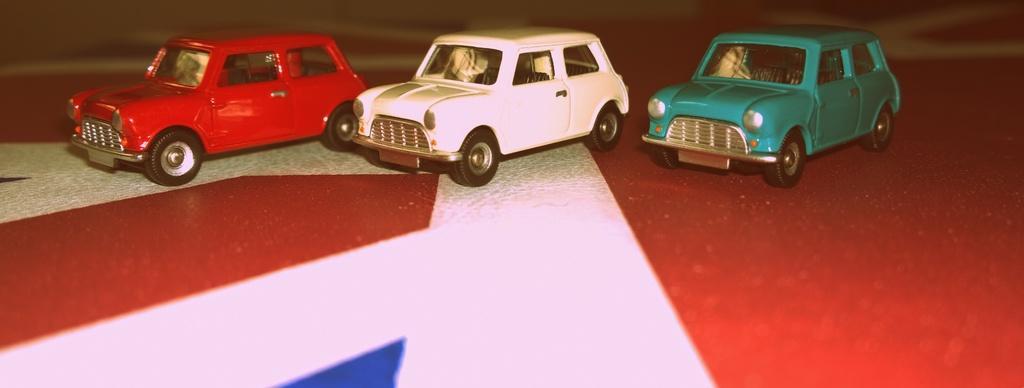Please provide a concise description of this image. In this picture we can see three toy cars, a car on the left side is of red color, a car in the middle is of white color, it looks like a green color car on the right side, there is a blurry background. 